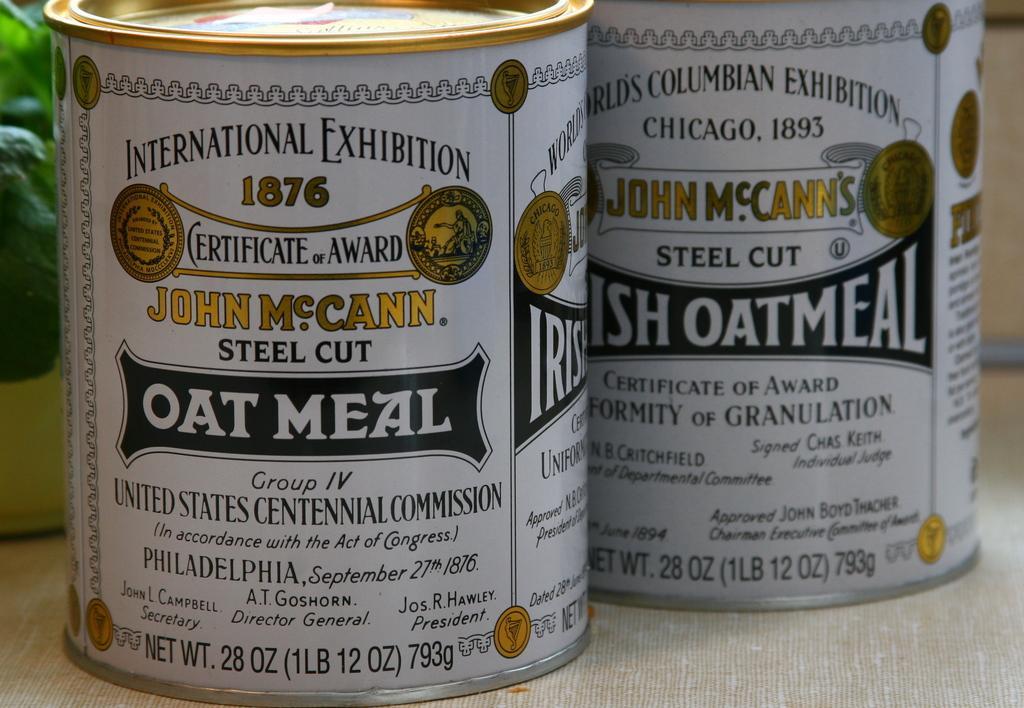Please provide a concise description of this image. There are two text written bottles are kept on the surface as we can see in the middle of this image. 